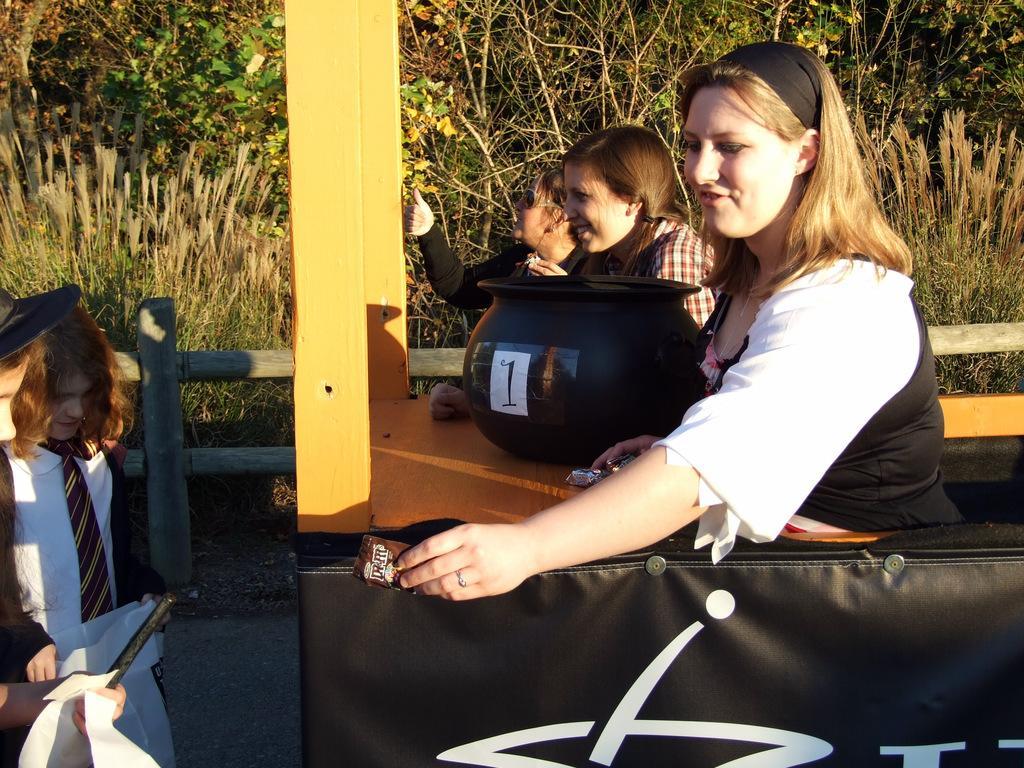Can you describe this image briefly? In this picture, it looks like a stall and in the stall there are three persons. There is a black object and a woman is holding some objects. At the bottom of the image, there is a banner. On the left side of the image, there are two kids holding some objects. Behind the stall, there are trees and a wooden fence. 